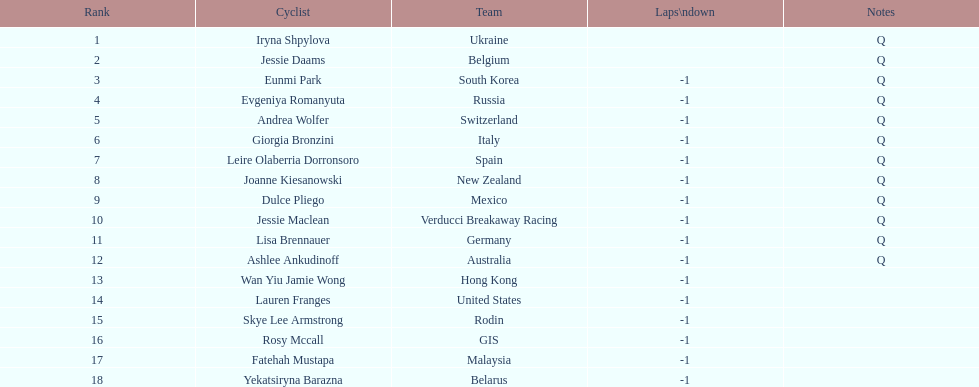Who was the one to finish before jessie maclean in the competition? Dulce Pliego. 